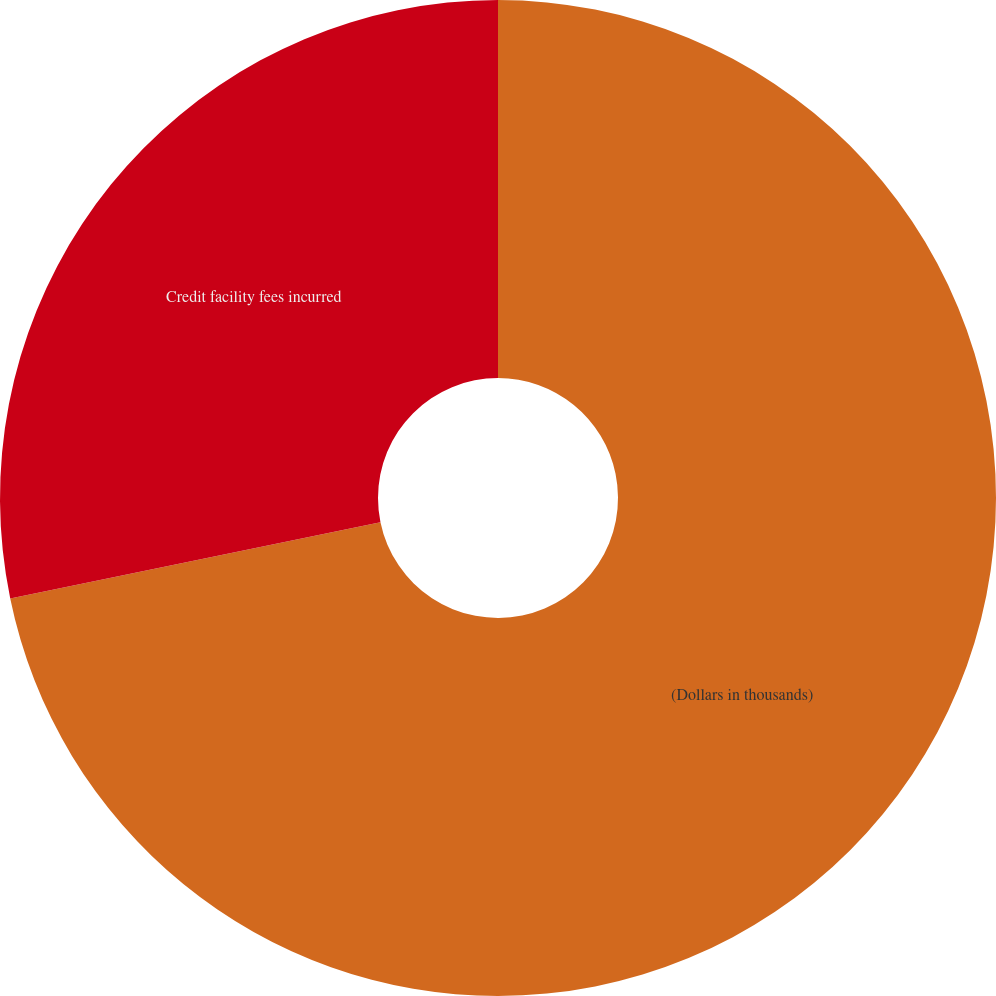<chart> <loc_0><loc_0><loc_500><loc_500><pie_chart><fcel>(Dollars in thousands)<fcel>Credit facility fees incurred<nl><fcel>71.77%<fcel>28.23%<nl></chart> 